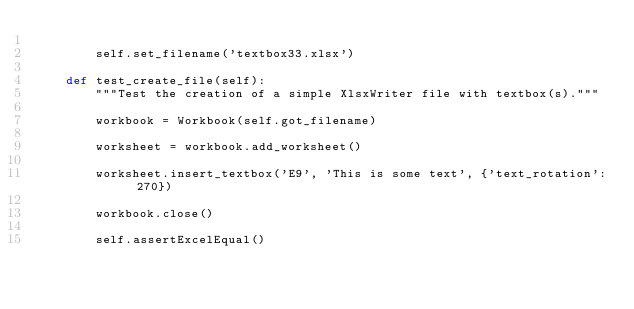<code> <loc_0><loc_0><loc_500><loc_500><_Python_>
        self.set_filename('textbox33.xlsx')

    def test_create_file(self):
        """Test the creation of a simple XlsxWriter file with textbox(s)."""

        workbook = Workbook(self.got_filename)

        worksheet = workbook.add_worksheet()

        worksheet.insert_textbox('E9', 'This is some text', {'text_rotation': 270})

        workbook.close()

        self.assertExcelEqual()
</code> 